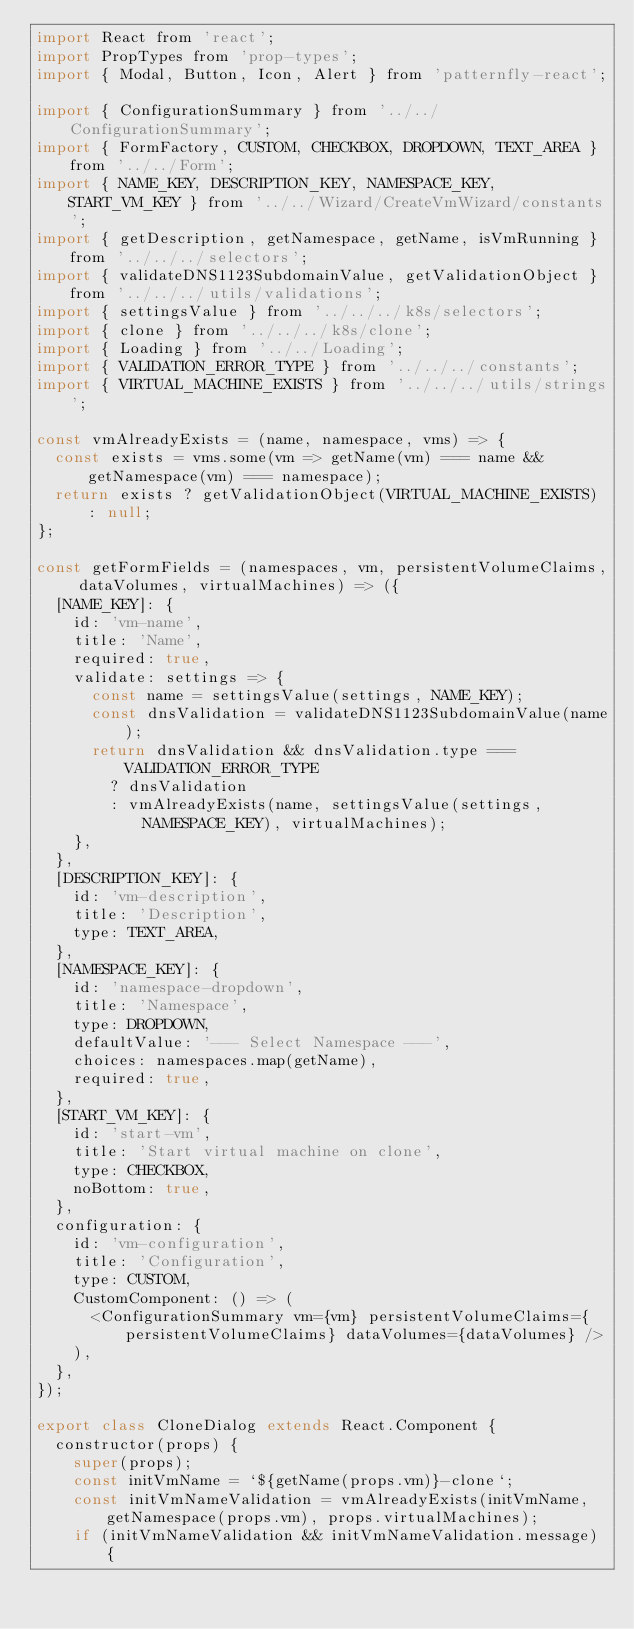<code> <loc_0><loc_0><loc_500><loc_500><_JavaScript_>import React from 'react';
import PropTypes from 'prop-types';
import { Modal, Button, Icon, Alert } from 'patternfly-react';

import { ConfigurationSummary } from '../../ConfigurationSummary';
import { FormFactory, CUSTOM, CHECKBOX, DROPDOWN, TEXT_AREA } from '../../Form';
import { NAME_KEY, DESCRIPTION_KEY, NAMESPACE_KEY, START_VM_KEY } from '../../Wizard/CreateVmWizard/constants';
import { getDescription, getNamespace, getName, isVmRunning } from '../../../selectors';
import { validateDNS1123SubdomainValue, getValidationObject } from '../../../utils/validations';
import { settingsValue } from '../../../k8s/selectors';
import { clone } from '../../../k8s/clone';
import { Loading } from '../../Loading';
import { VALIDATION_ERROR_TYPE } from '../../../constants';
import { VIRTUAL_MACHINE_EXISTS } from '../../../utils/strings';

const vmAlreadyExists = (name, namespace, vms) => {
  const exists = vms.some(vm => getName(vm) === name && getNamespace(vm) === namespace);
  return exists ? getValidationObject(VIRTUAL_MACHINE_EXISTS) : null;
};

const getFormFields = (namespaces, vm, persistentVolumeClaims, dataVolumes, virtualMachines) => ({
  [NAME_KEY]: {
    id: 'vm-name',
    title: 'Name',
    required: true,
    validate: settings => {
      const name = settingsValue(settings, NAME_KEY);
      const dnsValidation = validateDNS1123SubdomainValue(name);
      return dnsValidation && dnsValidation.type === VALIDATION_ERROR_TYPE
        ? dnsValidation
        : vmAlreadyExists(name, settingsValue(settings, NAMESPACE_KEY), virtualMachines);
    },
  },
  [DESCRIPTION_KEY]: {
    id: 'vm-description',
    title: 'Description',
    type: TEXT_AREA,
  },
  [NAMESPACE_KEY]: {
    id: 'namespace-dropdown',
    title: 'Namespace',
    type: DROPDOWN,
    defaultValue: '--- Select Namespace ---',
    choices: namespaces.map(getName),
    required: true,
  },
  [START_VM_KEY]: {
    id: 'start-vm',
    title: 'Start virtual machine on clone',
    type: CHECKBOX,
    noBottom: true,
  },
  configuration: {
    id: 'vm-configuration',
    title: 'Configuration',
    type: CUSTOM,
    CustomComponent: () => (
      <ConfigurationSummary vm={vm} persistentVolumeClaims={persistentVolumeClaims} dataVolumes={dataVolumes} />
    ),
  },
});

export class CloneDialog extends React.Component {
  constructor(props) {
    super(props);
    const initVmName = `${getName(props.vm)}-clone`;
    const initVmNameValidation = vmAlreadyExists(initVmName, getNamespace(props.vm), props.virtualMachines);
    if (initVmNameValidation && initVmNameValidation.message) {</code> 